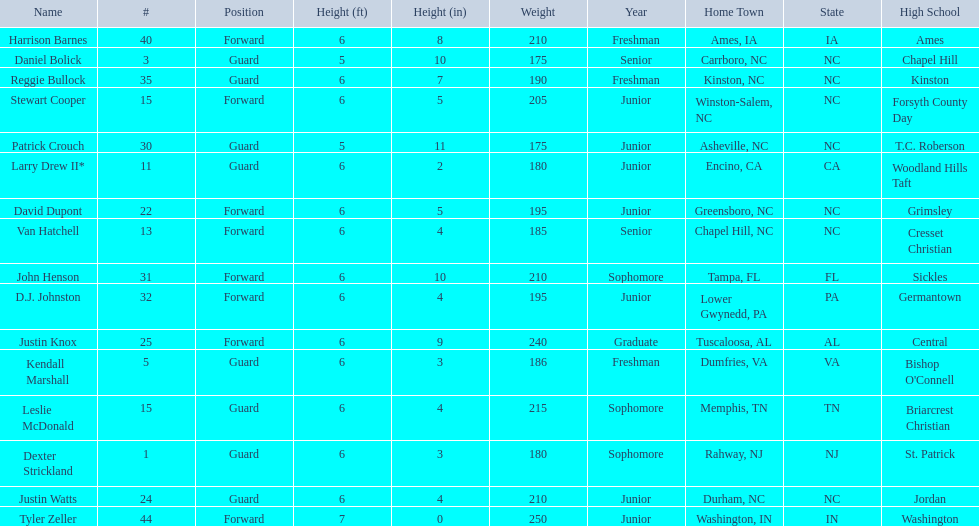Would you be able to parse every entry in this table? {'header': ['Name', '#', 'Position', 'Height (ft)', 'Height (in)', 'Weight', 'Year', 'Home Town', 'State', 'High School'], 'rows': [['Harrison Barnes', '40', 'Forward', '6', '8', '210', 'Freshman', 'Ames, IA', 'IA', 'Ames'], ['Daniel Bolick', '3', 'Guard', '5', '10', '175', 'Senior', 'Carrboro, NC', 'NC', 'Chapel Hill'], ['Reggie Bullock', '35', 'Guard', '6', '7', '190', 'Freshman', 'Kinston, NC', 'NC', 'Kinston'], ['Stewart Cooper', '15', 'Forward', '6', '5', '205', 'Junior', 'Winston-Salem, NC', 'NC', 'Forsyth County Day'], ['Patrick Crouch', '30', 'Guard', '5', '11', '175', 'Junior', 'Asheville, NC', 'NC', 'T.C. Roberson'], ['Larry Drew II*', '11', 'Guard', '6', '2', '180', 'Junior', 'Encino, CA', 'CA', 'Woodland Hills Taft'], ['David Dupont', '22', 'Forward', '6', '5', '195', 'Junior', 'Greensboro, NC', 'NC', 'Grimsley'], ['Van Hatchell', '13', 'Forward', '6', '4', '185', 'Senior', 'Chapel Hill, NC', 'NC', 'Cresset Christian'], ['John Henson', '31', 'Forward', '6', '10', '210', 'Sophomore', 'Tampa, FL', 'FL', 'Sickles'], ['D.J. Johnston', '32', 'Forward', '6', '4', '195', 'Junior', 'Lower Gwynedd, PA', 'PA', 'Germantown'], ['Justin Knox', '25', 'Forward', '6', '9', '240', 'Graduate', 'Tuscaloosa, AL', 'AL', 'Central'], ['Kendall Marshall', '5', 'Guard', '6', '3', '186', 'Freshman', 'Dumfries, VA', 'VA', "Bishop O'Connell"], ['Leslie McDonald', '15', 'Guard', '6', '4', '215', 'Sophomore', 'Memphis, TN', 'TN', 'Briarcrest Christian'], ['Dexter Strickland', '1', 'Guard', '6', '3', '180', 'Sophomore', 'Rahway, NJ', 'NJ', 'St. Patrick'], ['Justin Watts', '24', 'Guard', '6', '4', '210', 'Junior', 'Durham, NC', 'NC', 'Jordan'], ['Tyler Zeller', '44', 'Forward', '7', '0', '250', 'Junior', 'Washington, IN', 'IN', 'Washington']]} Names of players who were exactly 6 feet, 4 inches tall, but did not weight over 200 pounds Van Hatchell, D.J. Johnston. 